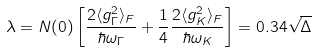<formula> <loc_0><loc_0><loc_500><loc_500>\lambda = N ( 0 ) \left [ \frac { 2 \langle g ^ { 2 } _ { \Gamma } \rangle _ { F } } { \hbar { \omega } _ { \Gamma } } + \frac { 1 } { 4 } \frac { 2 \langle g ^ { 2 } _ { K } \rangle _ { F } } { \hbar { \omega } _ { K } } \right ] = 0 . 3 4 \sqrt { \Delta }</formula> 